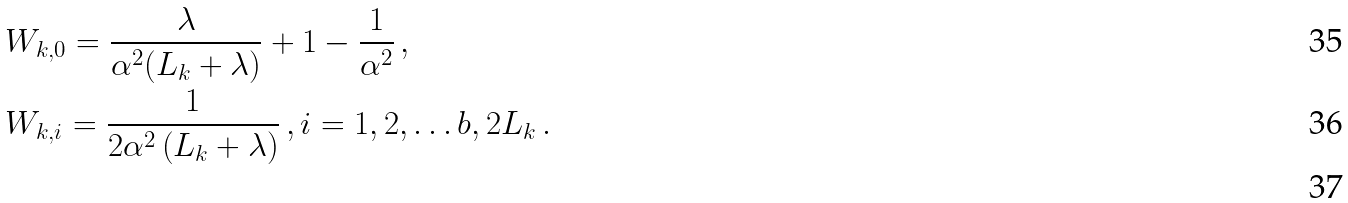Convert formula to latex. <formula><loc_0><loc_0><loc_500><loc_500>& W _ { k , 0 } = \frac { \lambda } { \alpha ^ { 2 } ( L _ { k } + \lambda ) } + 1 - \frac { 1 } { \alpha ^ { 2 } } \, , \\ & W _ { k , i } = \frac { 1 } { 2 \alpha ^ { 2 } \left ( L _ { k } + \lambda \right ) } \, , i = 1 , 2 , \dots b , 2 L _ { k } \, . \\</formula> 